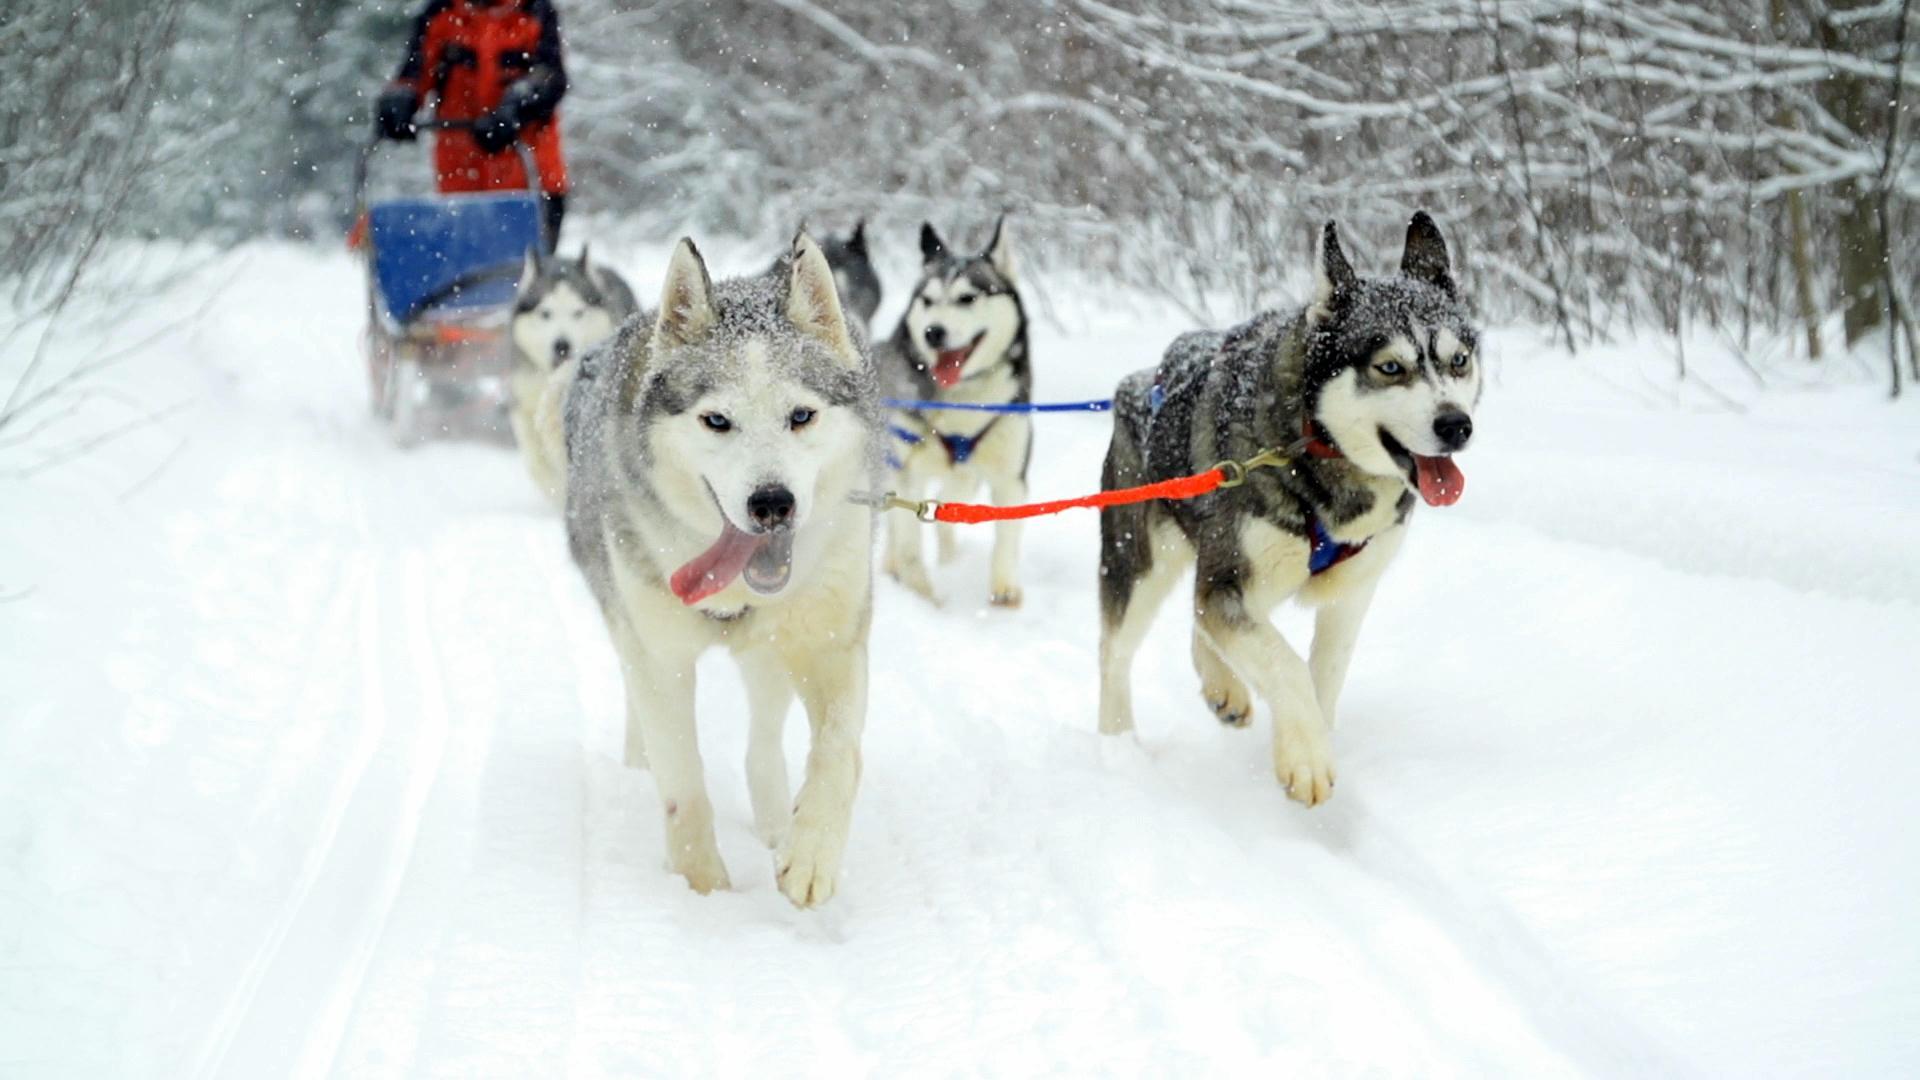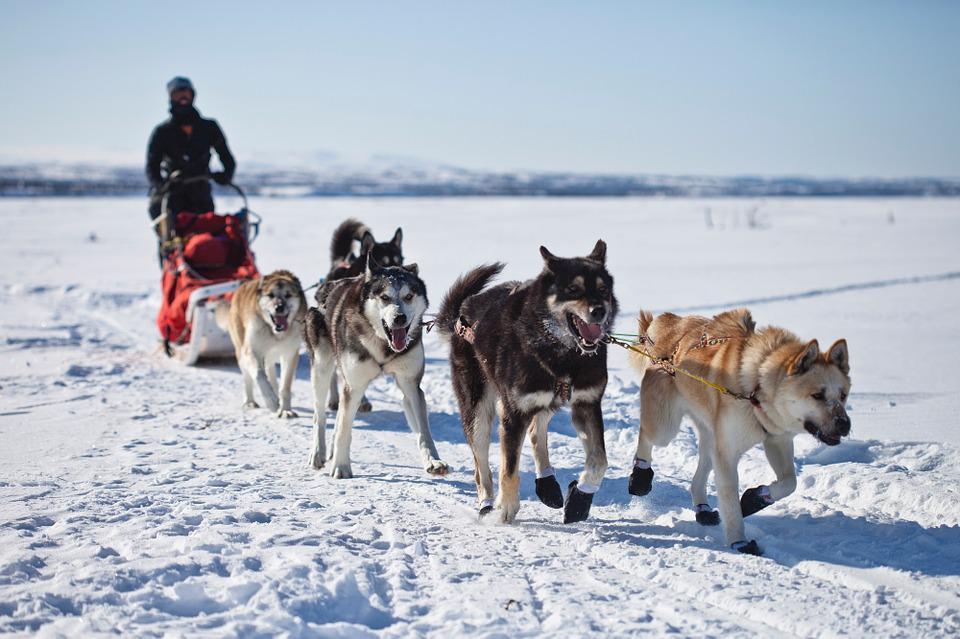The first image is the image on the left, the second image is the image on the right. Evaluate the accuracy of this statement regarding the images: "Right image shows a sled team heading rightward and downward, with no vegetation along the trail.". Is it true? Answer yes or no. Yes. 